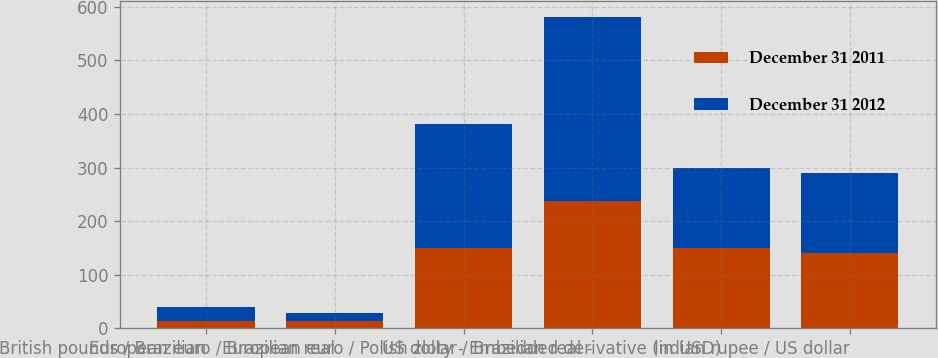Convert chart to OTSL. <chart><loc_0><loc_0><loc_500><loc_500><stacked_bar_chart><ecel><fcel>British pounds / Brazilian<fcel>European euro / Brazilian real<fcel>European euro / Polish zloty -<fcel>US dollar / Brazilian real -<fcel>Embedded derivative (in USD)<fcel>Indian rupee / US dollar<nl><fcel>December 31 2011<fcel>13<fcel>13<fcel>149<fcel>238<fcel>150<fcel>140<nl><fcel>December 31 2012<fcel>26<fcel>16<fcel>233<fcel>344<fcel>150<fcel>149<nl></chart> 